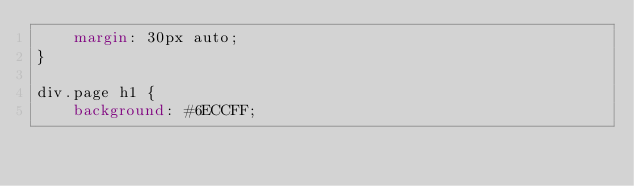Convert code to text. <code><loc_0><loc_0><loc_500><loc_500><_CSS_>    margin: 30px auto;
}

div.page h1 {
    background: #6ECCFF;</code> 